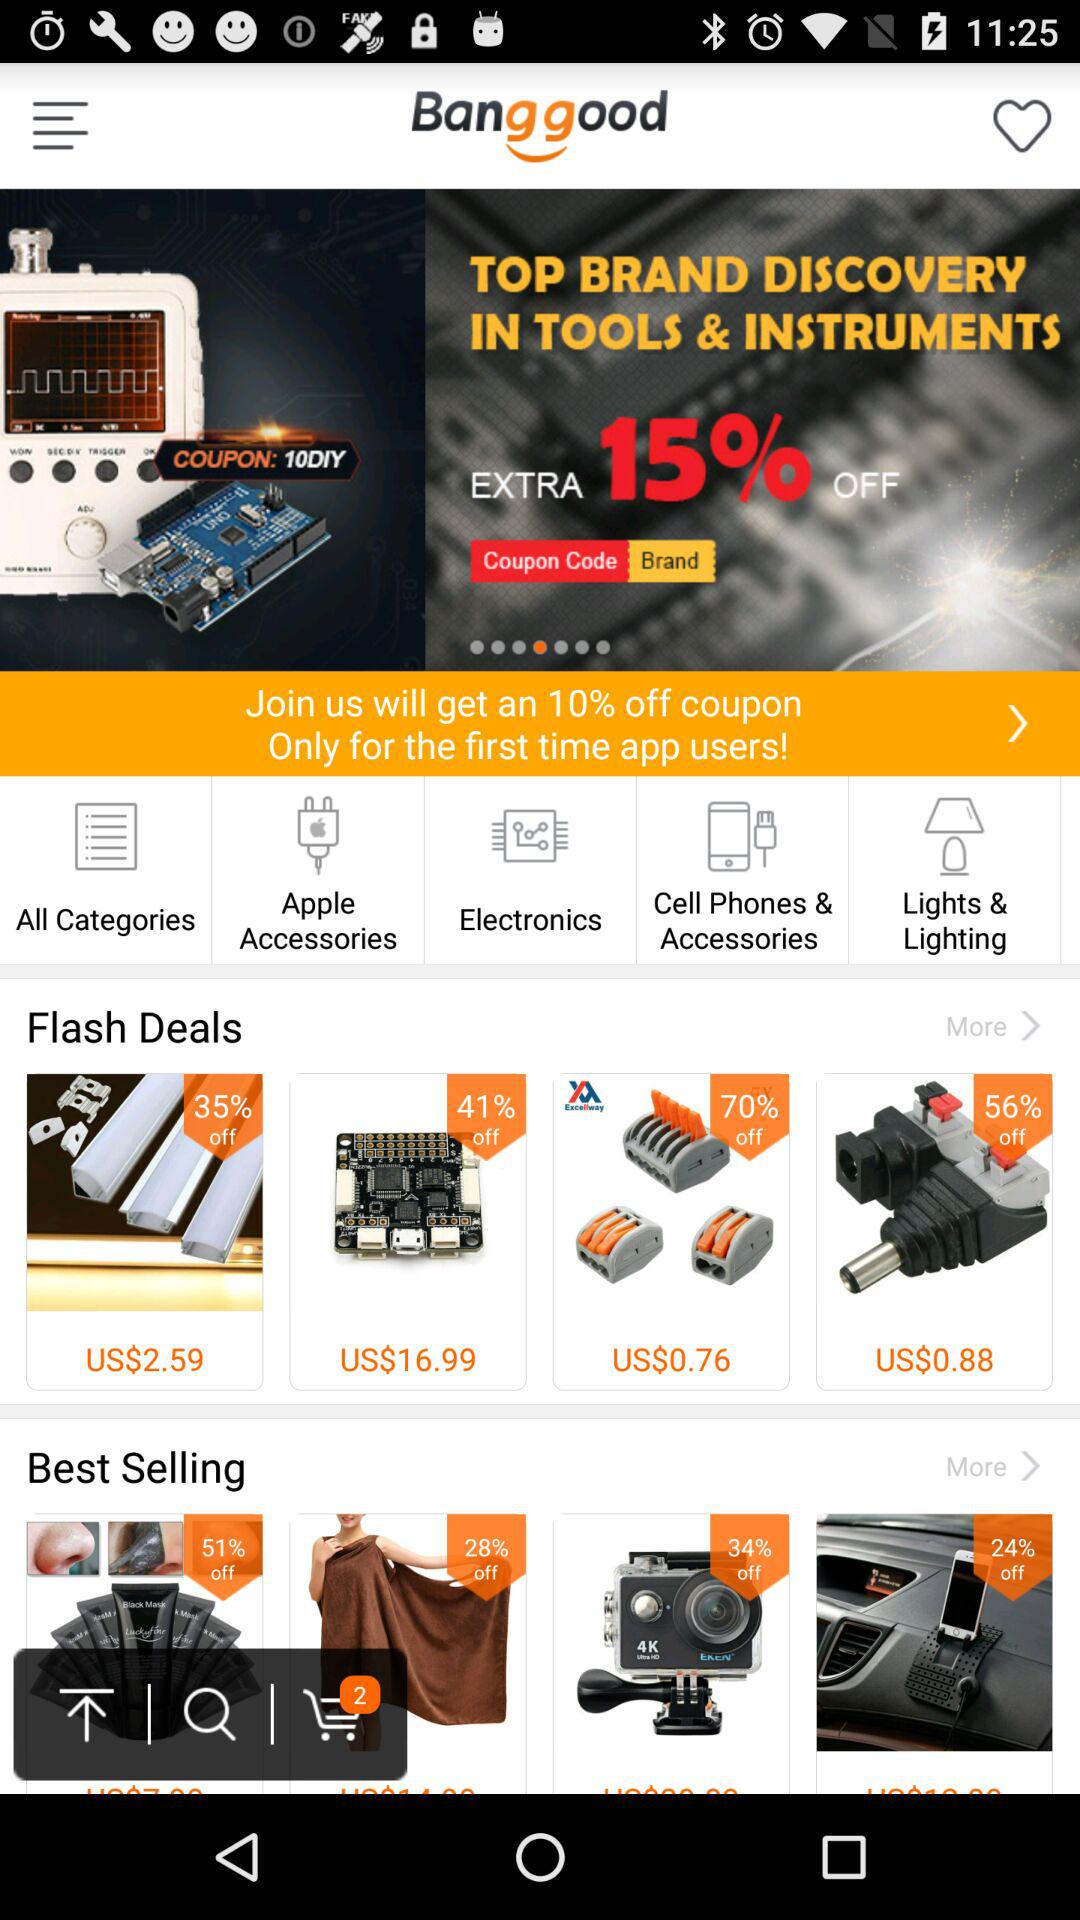What are the different categories available for shopping? The available categories are "Apple Accessories", "Electronics", "Cell Phones & Accessories", and "Lights & Lighting". 